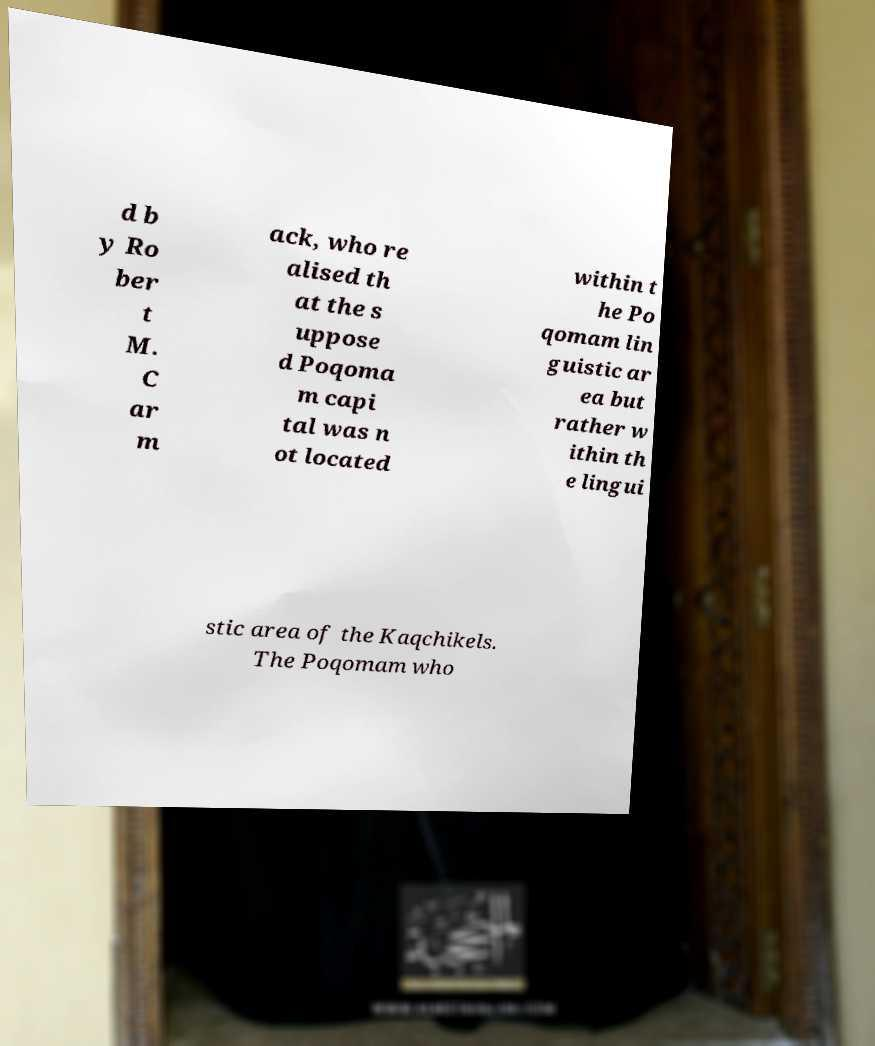What messages or text are displayed in this image? I need them in a readable, typed format. d b y Ro ber t M. C ar m ack, who re alised th at the s uppose d Poqoma m capi tal was n ot located within t he Po qomam lin guistic ar ea but rather w ithin th e lingui stic area of the Kaqchikels. The Poqomam who 